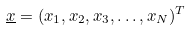Convert formula to latex. <formula><loc_0><loc_0><loc_500><loc_500>\underline { x } = ( x _ { 1 } , x _ { 2 } , x _ { 3 } , \dots , x _ { N } ) ^ { T }</formula> 